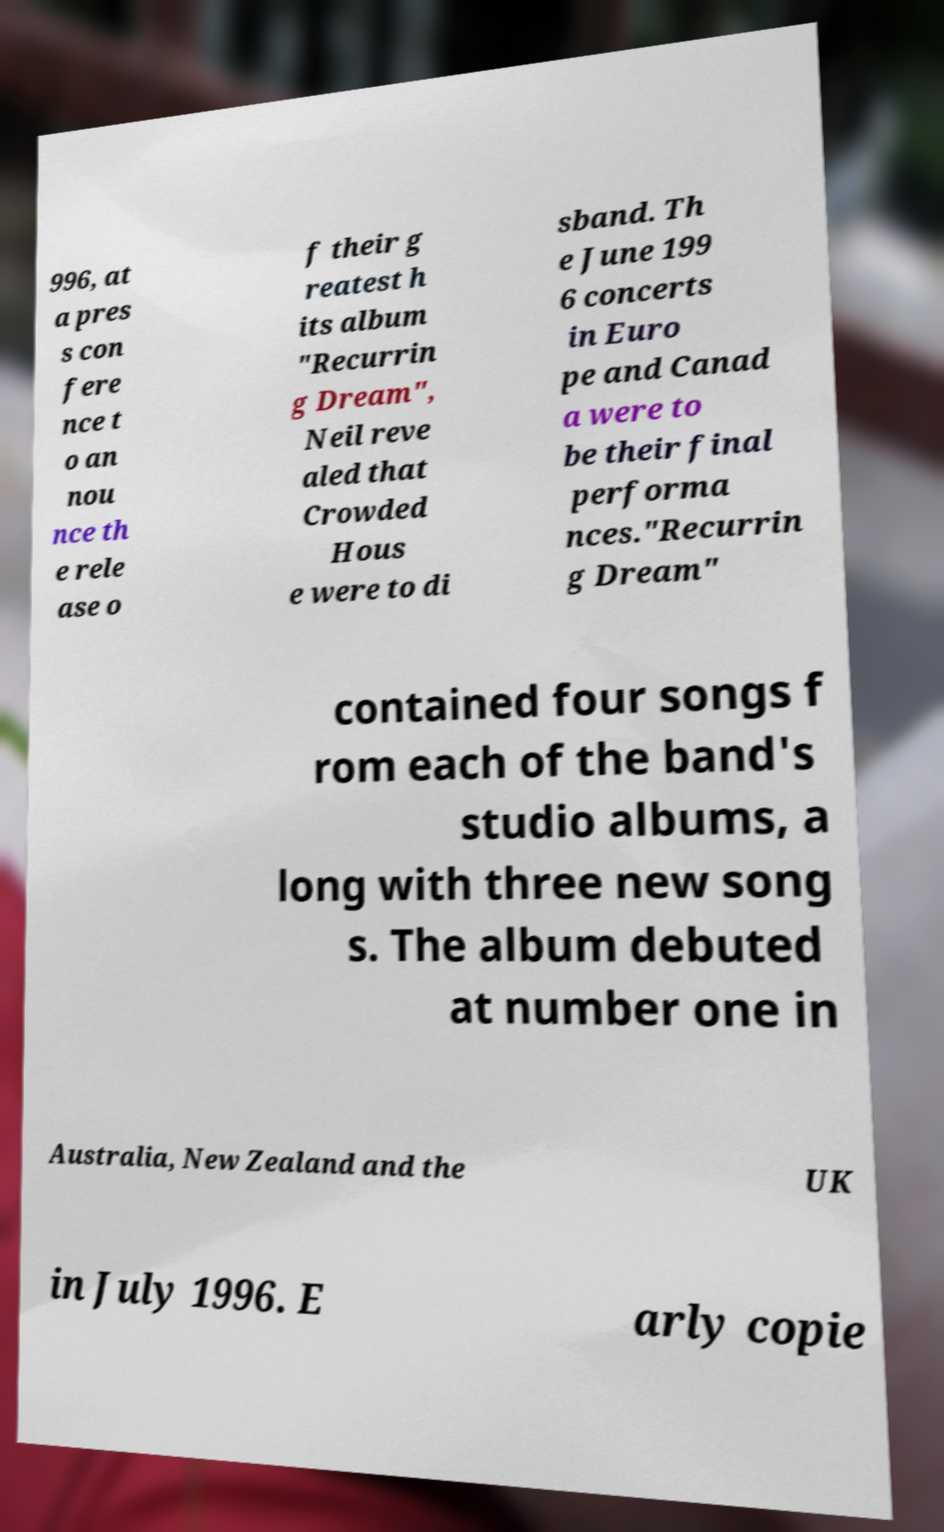Could you assist in decoding the text presented in this image and type it out clearly? 996, at a pres s con fere nce t o an nou nce th e rele ase o f their g reatest h its album "Recurrin g Dream", Neil reve aled that Crowded Hous e were to di sband. Th e June 199 6 concerts in Euro pe and Canad a were to be their final performa nces."Recurrin g Dream" contained four songs f rom each of the band's studio albums, a long with three new song s. The album debuted at number one in Australia, New Zealand and the UK in July 1996. E arly copie 